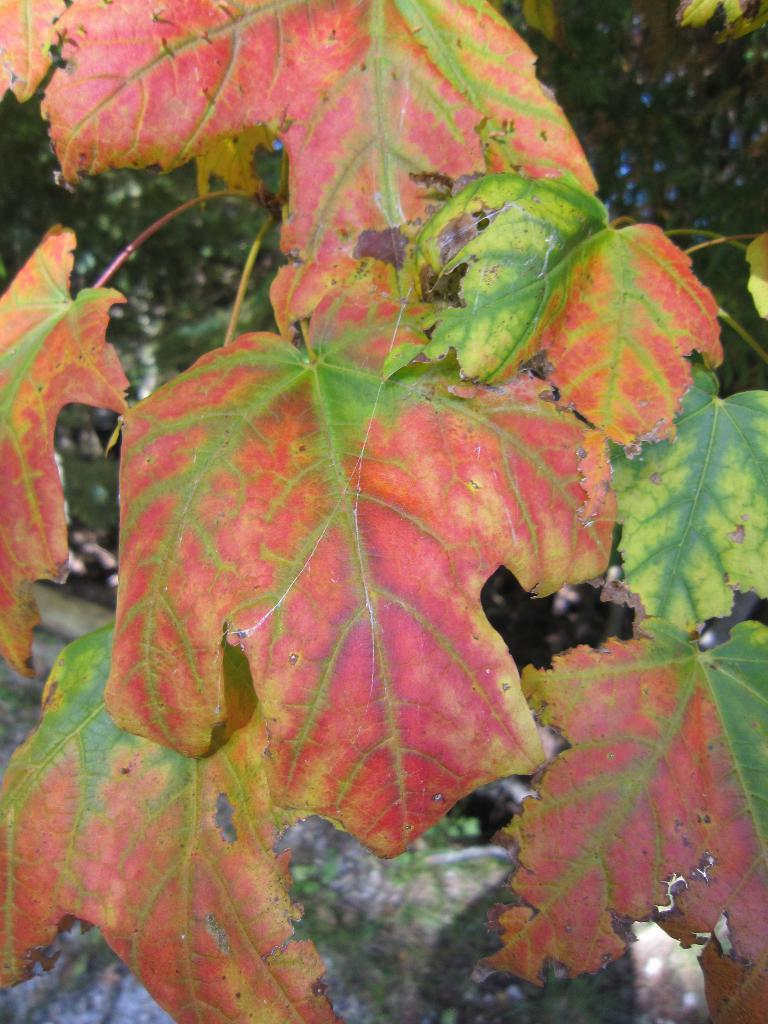What can be seen in the foreground of the picture? There are leaves in the foreground of the picture. How would you describe the background of the image? The background of the image is blurred. What type of natural elements are visible in the background? There are trees and a rock in the background of the image. Can you see any balloons tied to the rock in the image? There are no balloons present in the image; it only features leaves in the foreground and trees and a rock in the background. Are there any visible feet in the image? There is no mention of feet or any people in the image, so it cannot be determined if any are present. 